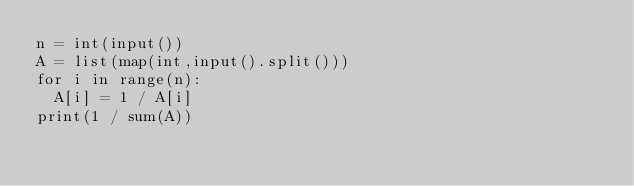<code> <loc_0><loc_0><loc_500><loc_500><_Python_>n = int(input())
A = list(map(int,input().split()))
for i in range(n):
  A[i] = 1 / A[i]
print(1 / sum(A))</code> 